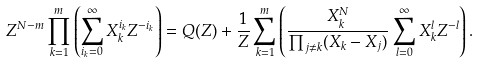<formula> <loc_0><loc_0><loc_500><loc_500>Z ^ { N - m } \prod _ { k = 1 } ^ { m } \left ( \sum _ { i _ { k } = 0 } ^ { \infty } X _ { k } ^ { i _ { k } } Z ^ { - i _ { k } } \right ) = Q ( Z ) + \frac { 1 } { Z } \sum _ { k = 1 } ^ { m } \left ( \frac { X _ { k } ^ { N } } { \prod _ { j \neq k } ( X _ { k } - X _ { j } ) } \sum _ { l = 0 } ^ { \infty } X _ { k } ^ { l } Z ^ { - l } \right ) .</formula> 